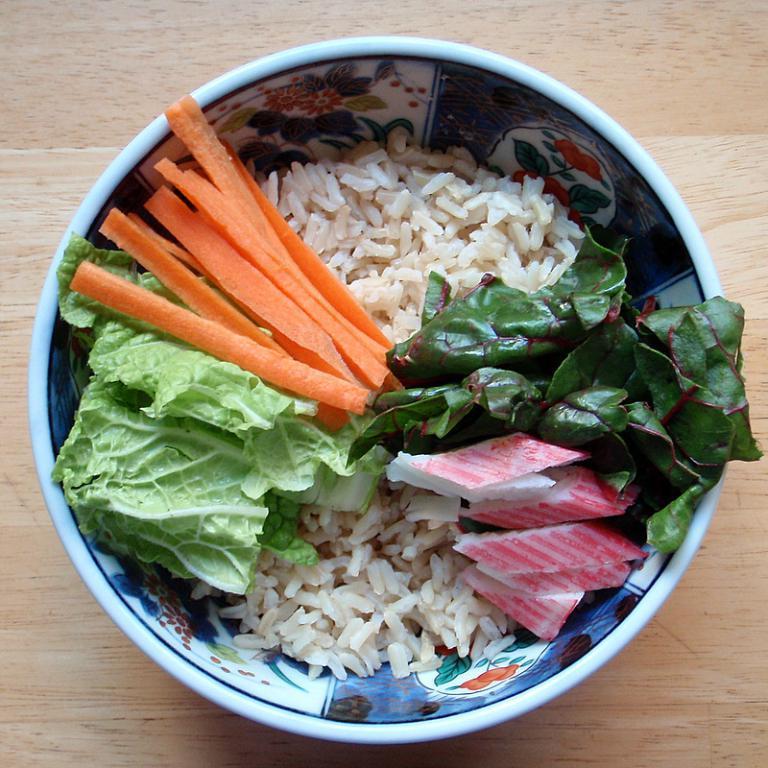Could you give a brief overview of what you see in this image? This is the picture of a bowl in which there is a rice, leafy vegetables and some carrot slices on it. 